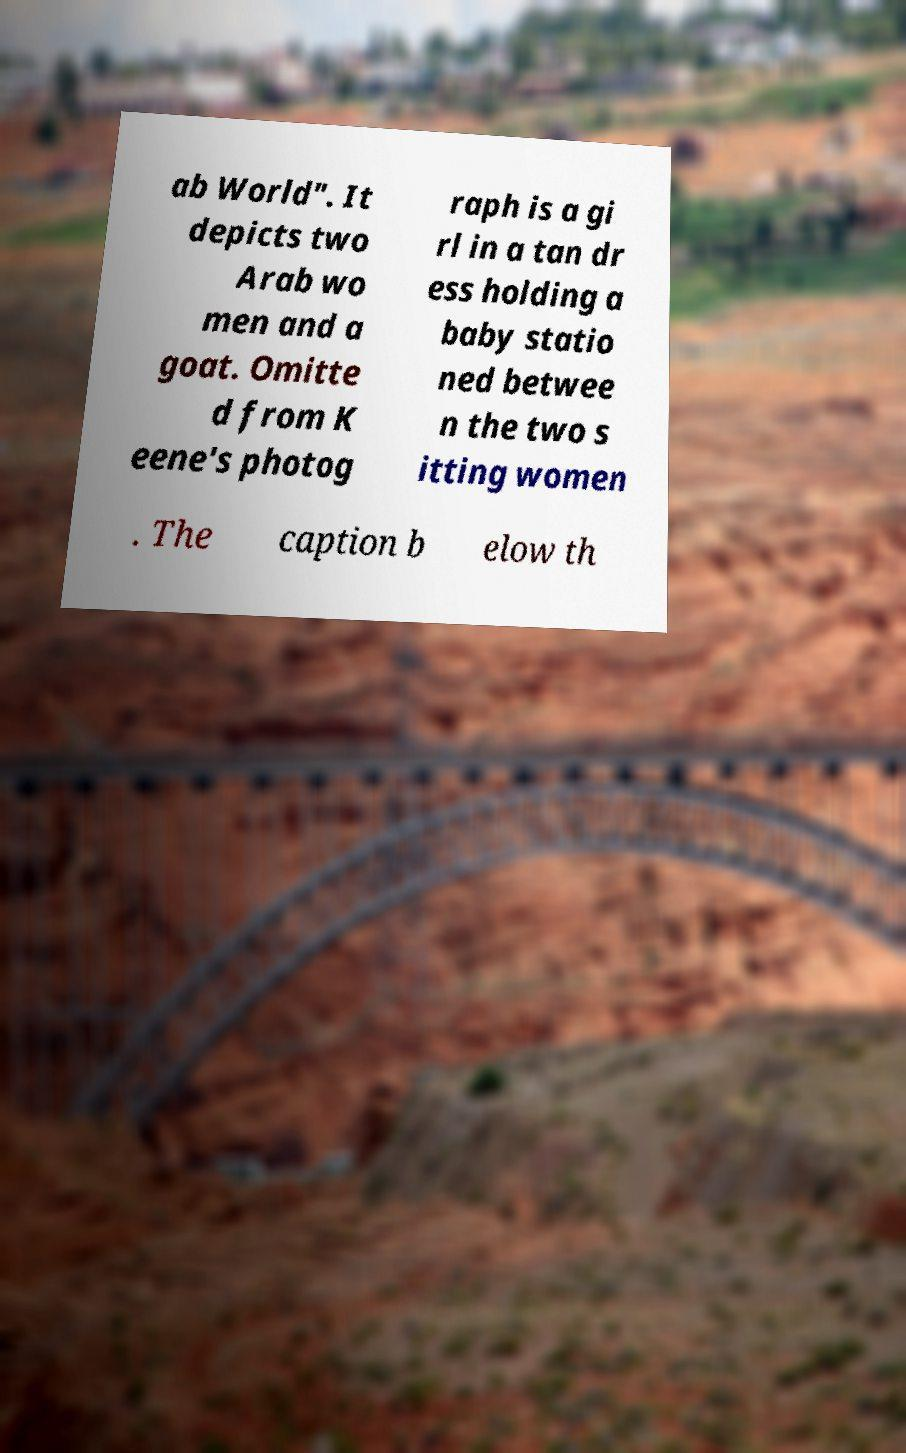Can you read and provide the text displayed in the image?This photo seems to have some interesting text. Can you extract and type it out for me? ab World". It depicts two Arab wo men and a goat. Omitte d from K eene's photog raph is a gi rl in a tan dr ess holding a baby statio ned betwee n the two s itting women . The caption b elow th 